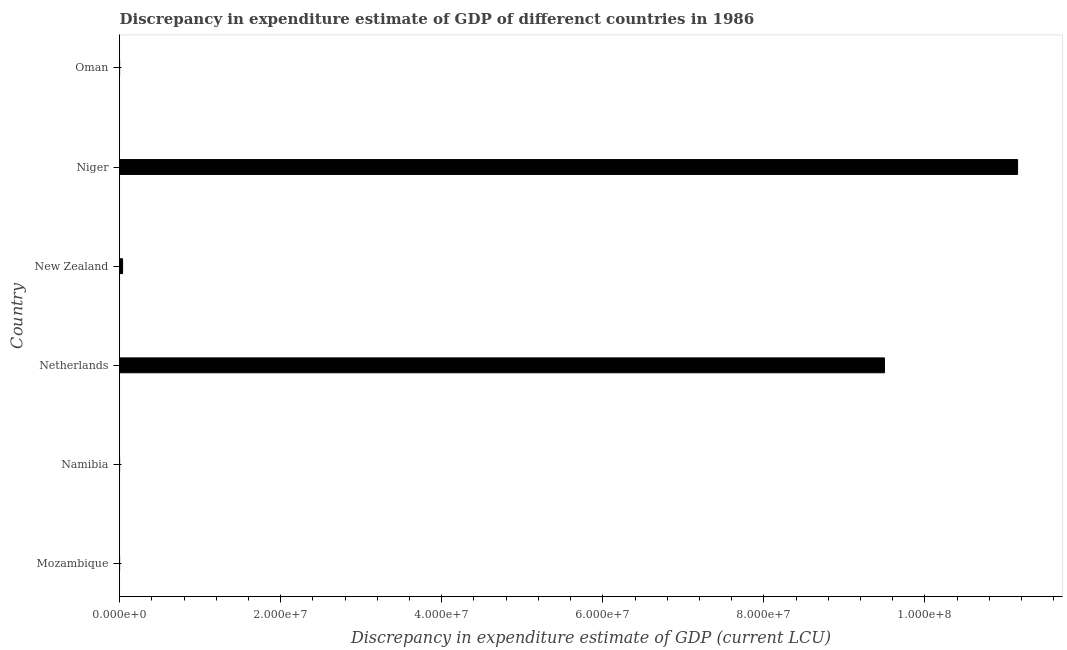Does the graph contain grids?
Make the answer very short. No. What is the title of the graph?
Make the answer very short. Discrepancy in expenditure estimate of GDP of differenct countries in 1986. What is the label or title of the X-axis?
Offer a terse response. Discrepancy in expenditure estimate of GDP (current LCU). What is the discrepancy in expenditure estimate of gdp in Oman?
Your response must be concise. 0. Across all countries, what is the maximum discrepancy in expenditure estimate of gdp?
Your answer should be very brief. 1.11e+08. In which country was the discrepancy in expenditure estimate of gdp maximum?
Your response must be concise. Niger. What is the sum of the discrepancy in expenditure estimate of gdp?
Your answer should be compact. 2.07e+08. What is the difference between the discrepancy in expenditure estimate of gdp in New Zealand and Niger?
Offer a very short reply. -1.11e+08. What is the average discrepancy in expenditure estimate of gdp per country?
Offer a very short reply. 3.45e+07. What is the median discrepancy in expenditure estimate of gdp?
Ensure brevity in your answer.  1.86e+05. In how many countries, is the discrepancy in expenditure estimate of gdp greater than 8000000 LCU?
Provide a succinct answer. 2. What is the ratio of the discrepancy in expenditure estimate of gdp in Netherlands to that in New Zealand?
Give a very brief answer. 255.57. What is the difference between the highest and the second highest discrepancy in expenditure estimate of gdp?
Offer a very short reply. 1.65e+07. What is the difference between the highest and the lowest discrepancy in expenditure estimate of gdp?
Provide a succinct answer. 1.11e+08. How many bars are there?
Your answer should be very brief. 3. Are all the bars in the graph horizontal?
Your answer should be very brief. Yes. How many countries are there in the graph?
Offer a very short reply. 6. What is the difference between two consecutive major ticks on the X-axis?
Make the answer very short. 2.00e+07. What is the Discrepancy in expenditure estimate of GDP (current LCU) in Namibia?
Your response must be concise. 0. What is the Discrepancy in expenditure estimate of GDP (current LCU) of Netherlands?
Provide a succinct answer. 9.50e+07. What is the Discrepancy in expenditure estimate of GDP (current LCU) in New Zealand?
Provide a succinct answer. 3.72e+05. What is the Discrepancy in expenditure estimate of GDP (current LCU) in Niger?
Keep it short and to the point. 1.11e+08. What is the Discrepancy in expenditure estimate of GDP (current LCU) in Oman?
Your answer should be very brief. 0. What is the difference between the Discrepancy in expenditure estimate of GDP (current LCU) in Netherlands and New Zealand?
Your answer should be compact. 9.46e+07. What is the difference between the Discrepancy in expenditure estimate of GDP (current LCU) in Netherlands and Niger?
Provide a short and direct response. -1.65e+07. What is the difference between the Discrepancy in expenditure estimate of GDP (current LCU) in New Zealand and Niger?
Keep it short and to the point. -1.11e+08. What is the ratio of the Discrepancy in expenditure estimate of GDP (current LCU) in Netherlands to that in New Zealand?
Provide a short and direct response. 255.57. What is the ratio of the Discrepancy in expenditure estimate of GDP (current LCU) in Netherlands to that in Niger?
Offer a terse response. 0.85. What is the ratio of the Discrepancy in expenditure estimate of GDP (current LCU) in New Zealand to that in Niger?
Your answer should be compact. 0. 